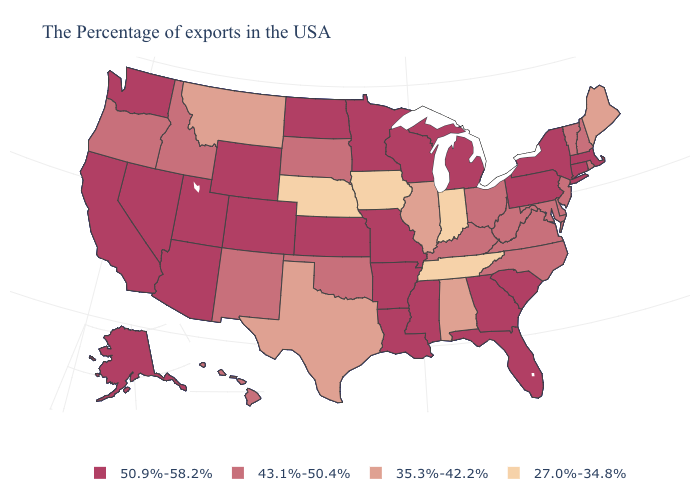Which states have the lowest value in the USA?
Quick response, please. Indiana, Tennessee, Iowa, Nebraska. How many symbols are there in the legend?
Keep it brief. 4. Does the first symbol in the legend represent the smallest category?
Keep it brief. No. Name the states that have a value in the range 35.3%-42.2%?
Be succinct. Maine, Alabama, Illinois, Texas, Montana. What is the value of Arizona?
Give a very brief answer. 50.9%-58.2%. What is the lowest value in states that border Florida?
Keep it brief. 35.3%-42.2%. What is the value of Maryland?
Answer briefly. 43.1%-50.4%. What is the value of Florida?
Give a very brief answer. 50.9%-58.2%. What is the value of New Hampshire?
Keep it brief. 43.1%-50.4%. Does Ohio have the lowest value in the USA?
Short answer required. No. What is the lowest value in states that border Mississippi?
Keep it brief. 27.0%-34.8%. What is the highest value in the USA?
Write a very short answer. 50.9%-58.2%. What is the highest value in the South ?
Concise answer only. 50.9%-58.2%. What is the value of Nebraska?
Keep it brief. 27.0%-34.8%. Name the states that have a value in the range 43.1%-50.4%?
Give a very brief answer. Rhode Island, New Hampshire, Vermont, New Jersey, Delaware, Maryland, Virginia, North Carolina, West Virginia, Ohio, Kentucky, Oklahoma, South Dakota, New Mexico, Idaho, Oregon, Hawaii. 